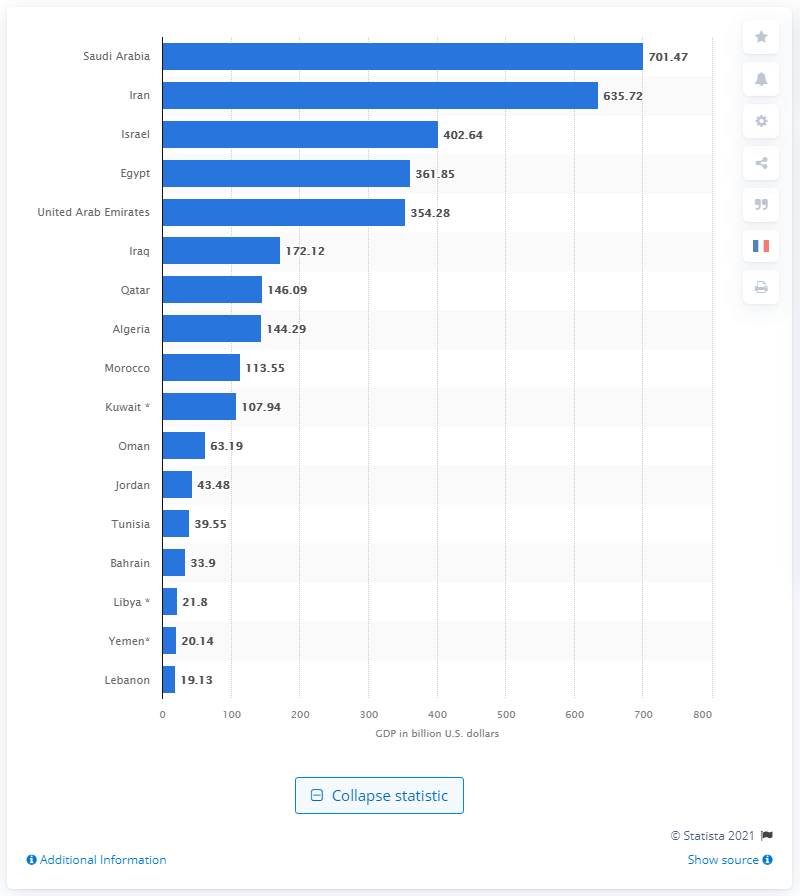Outline some significant characteristics in this image. According to the data available, the Gross Domestic Product (GDP) of Algeria was 144.29 billion dollars in 2020. 